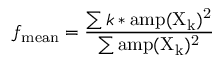Convert formula to latex. <formula><loc_0><loc_0><loc_500><loc_500>f _ { m e a n } = \frac { \sum k * a m p ( X _ { k } ) ^ { 2 } } { \sum a m p ( X _ { k } ) ^ { 2 } }</formula> 